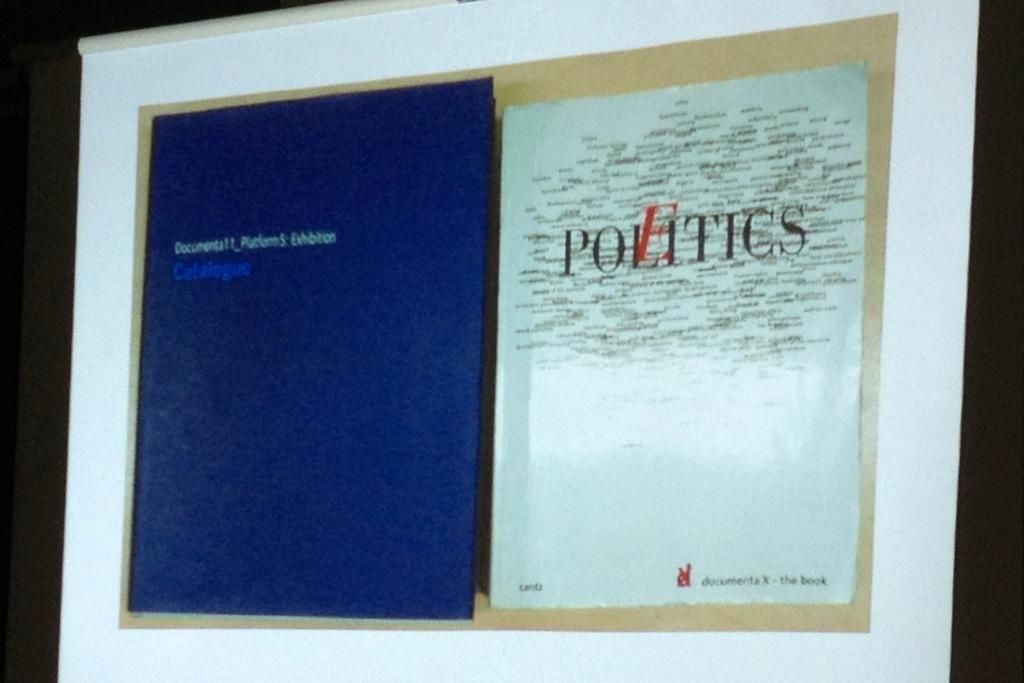<image>
Render a clear and concise summary of the photo. A blue book has the word catalogue on it. 